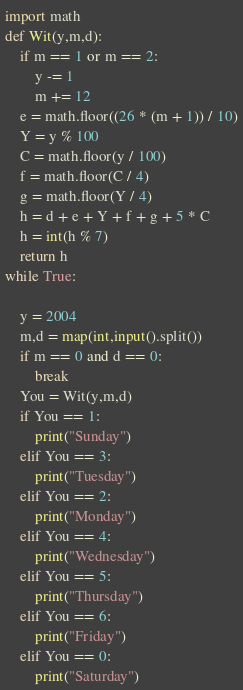Convert code to text. <code><loc_0><loc_0><loc_500><loc_500><_Python_>import math
def Wit(y,m,d):
    if m == 1 or m == 2:
        y -= 1
        m += 12
    e = math.floor((26 * (m + 1)) / 10)
    Y = y % 100
    C = math.floor(y / 100)
    f = math.floor(C / 4)
    g = math.floor(Y / 4)
    h = d + e + Y + f + g + 5 * C
    h = int(h % 7)
    return h
while True:

    y = 2004
    m,d = map(int,input().split())
    if m == 0 and d == 0:
        break
    You = Wit(y,m,d)
    if You == 1:
        print("Sunday")
    elif You == 3:
        print("Tuesday")
    elif You == 2:
        print("Monday")
    elif You == 4:
        print("Wednesday")
    elif You == 5:
        print("Thursday")
    elif You == 6:
        print("Friday")
    elif You == 0:
        print("Saturday")</code> 